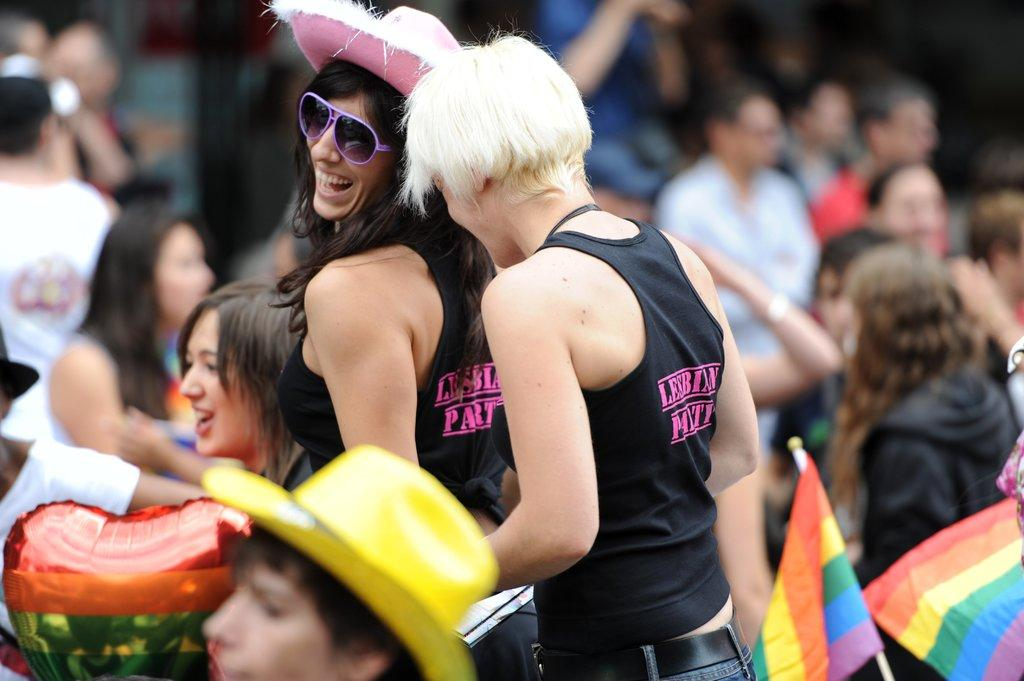How many people are present in the image? There are many people in the image. What are the people wearing? The people are wearing clothes. Are there any accessories visible on some people? Yes, some people are wearing caps. What can be seen besides the people in the image? There is a flag, goggles, and a balloon in the image. How are the people in the image feeling? The people in the image are smiling. What type of harmony is being played on the oven in the image? There is no oven present in the image, and therefore no music or harmony can be heard. 